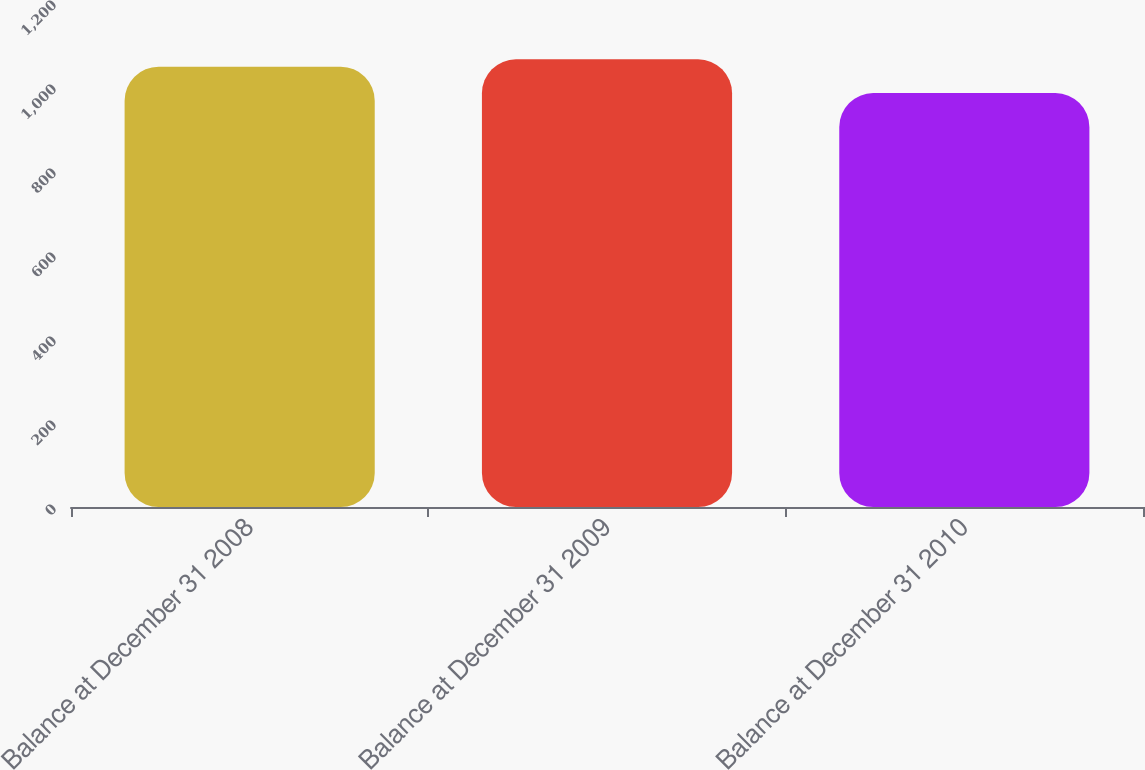Convert chart to OTSL. <chart><loc_0><loc_0><loc_500><loc_500><bar_chart><fcel>Balance at December 31 2008<fcel>Balance at December 31 2009<fcel>Balance at December 31 2010<nl><fcel>1048.3<fcel>1065.9<fcel>985.6<nl></chart> 